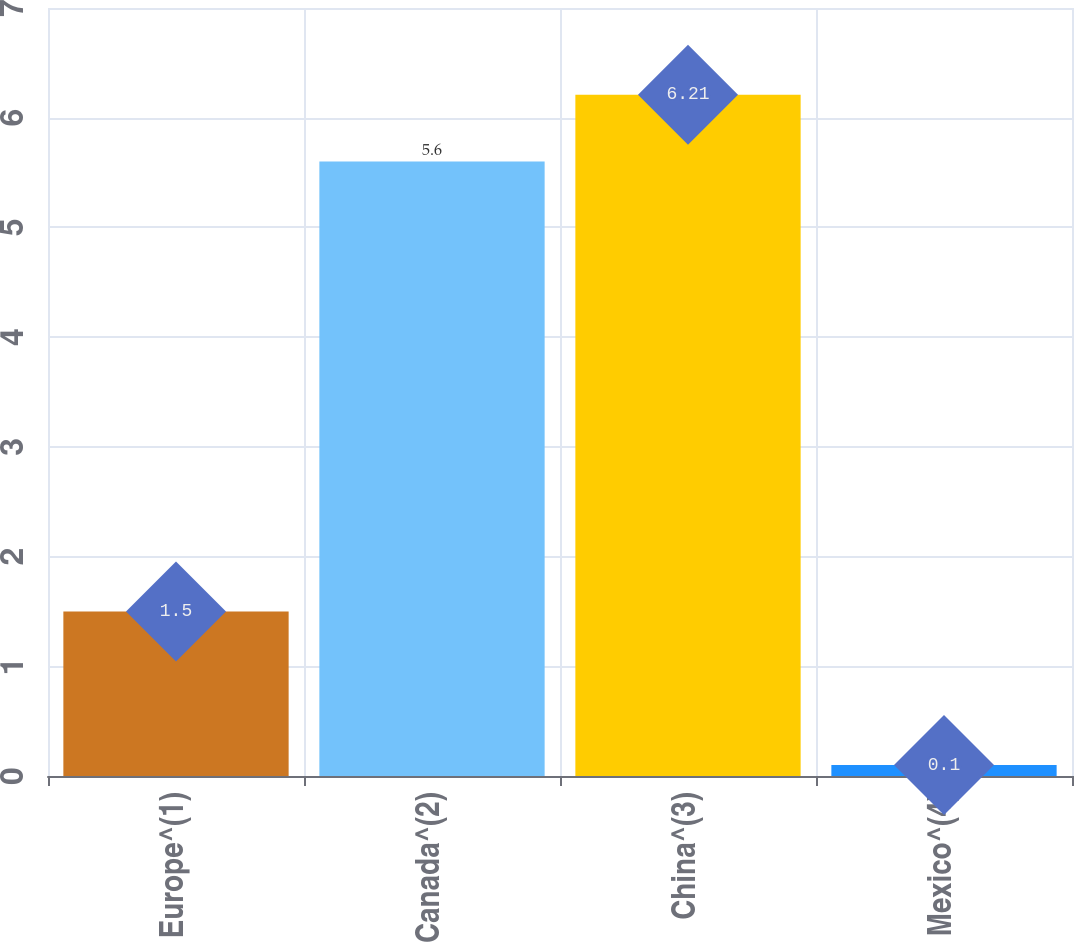Convert chart. <chart><loc_0><loc_0><loc_500><loc_500><bar_chart><fcel>Europe^(1)<fcel>Canada^(2)<fcel>China^(3)<fcel>Mexico^(4)<nl><fcel>1.5<fcel>5.6<fcel>6.21<fcel>0.1<nl></chart> 